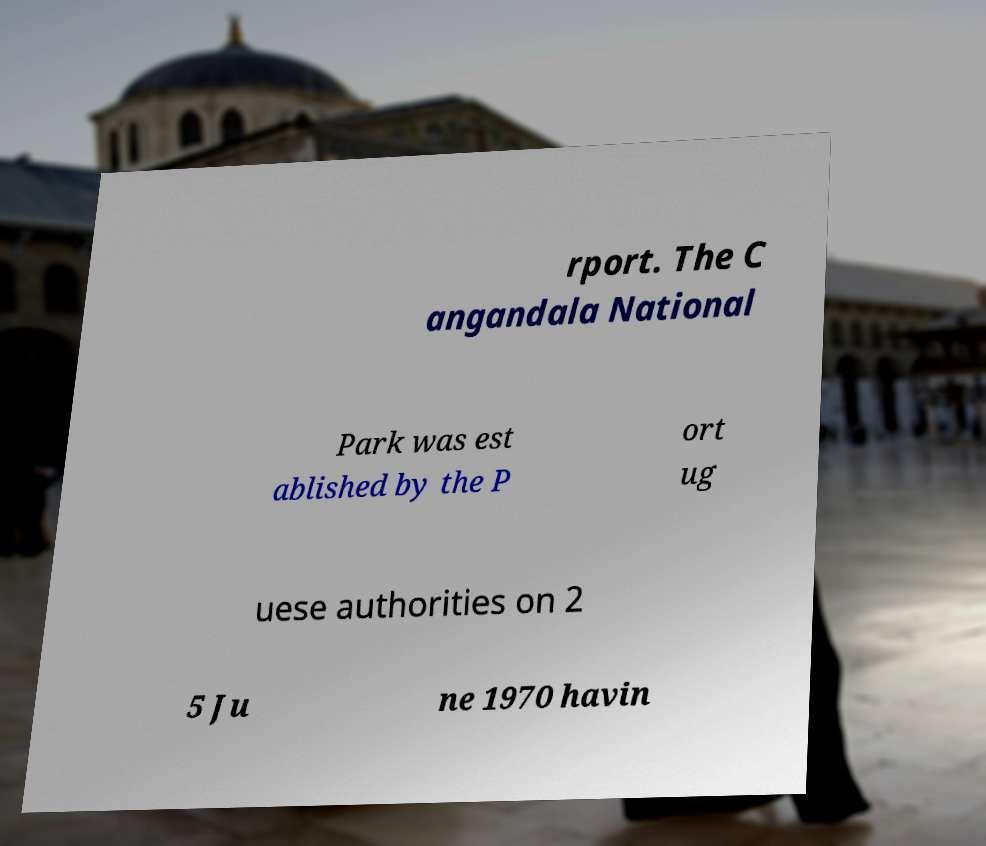Can you accurately transcribe the text from the provided image for me? rport. The C angandala National Park was est ablished by the P ort ug uese authorities on 2 5 Ju ne 1970 havin 